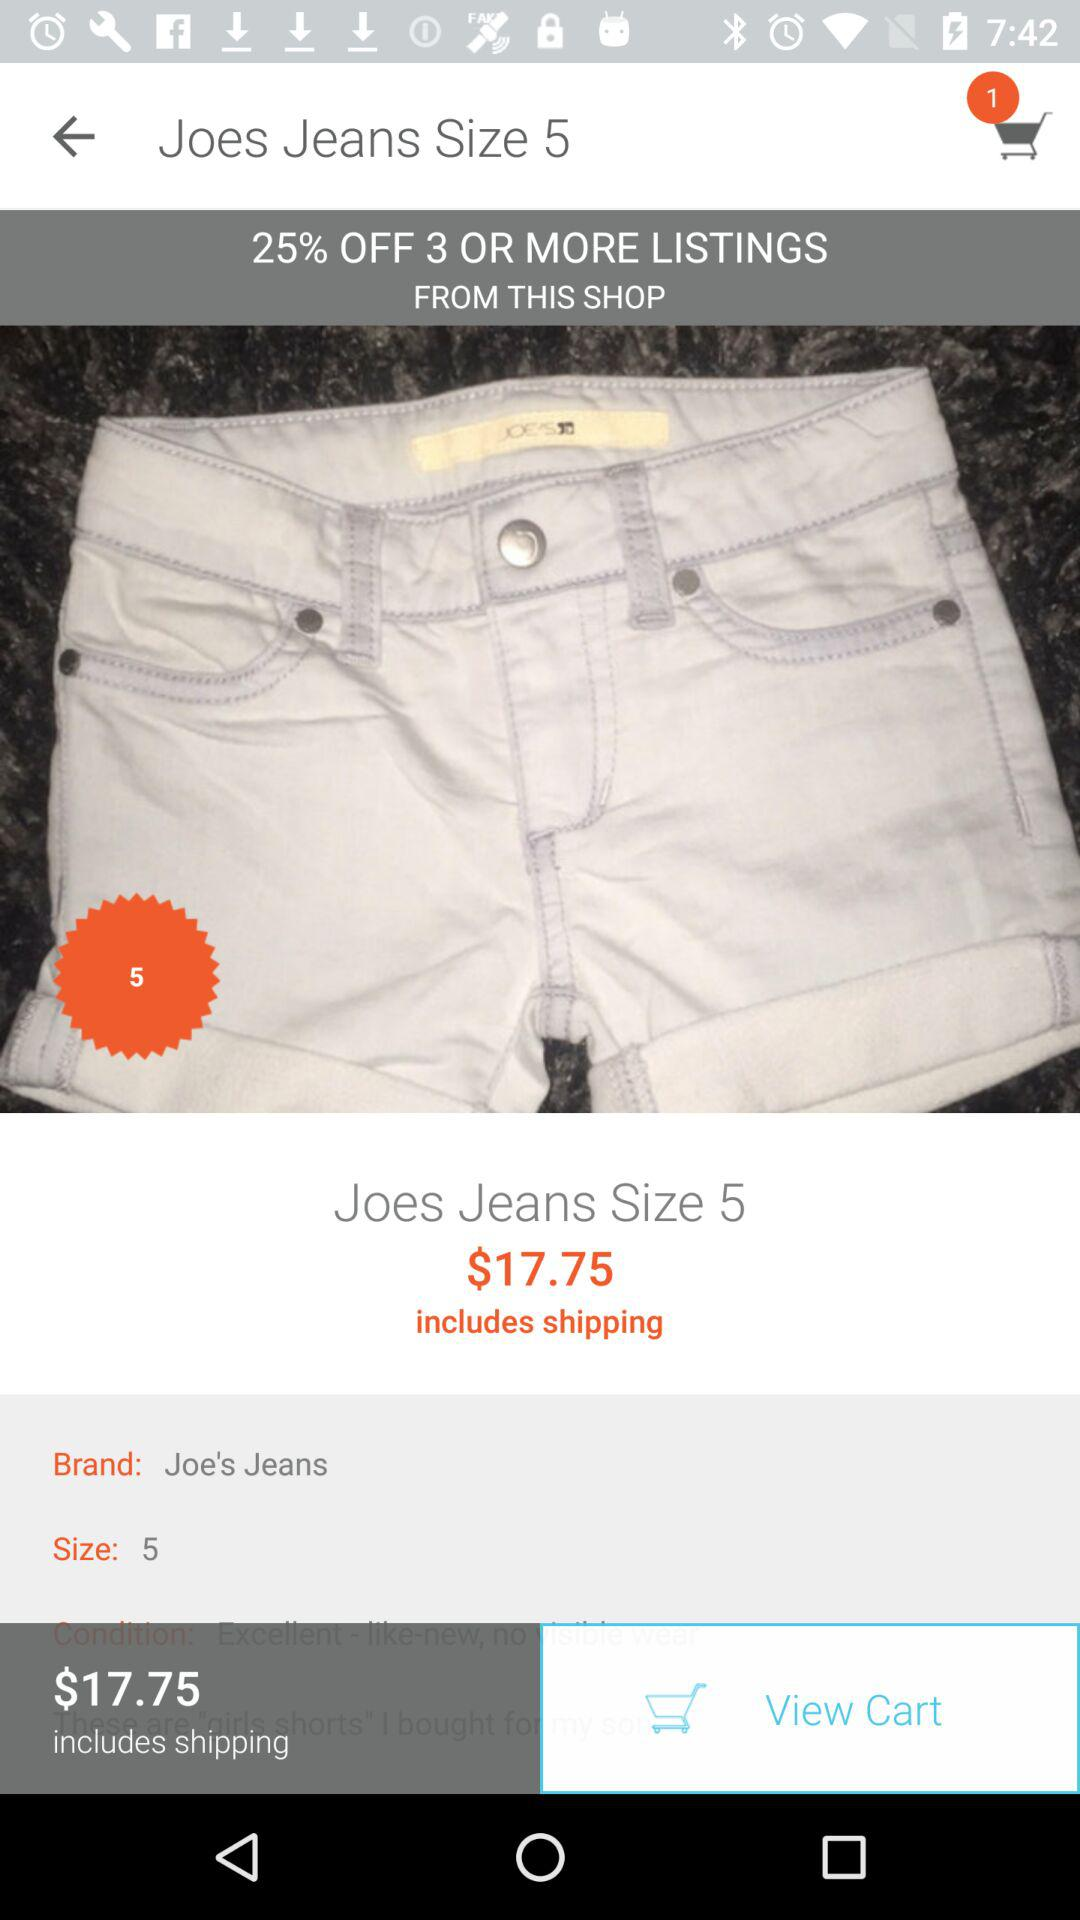What's the off percent on 3 or more listings from this shop? The off percentage is 25. 